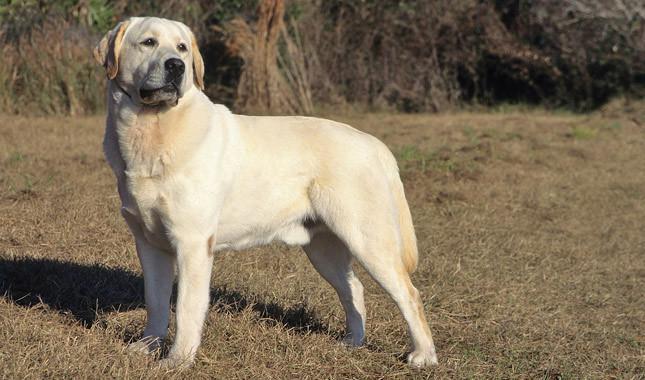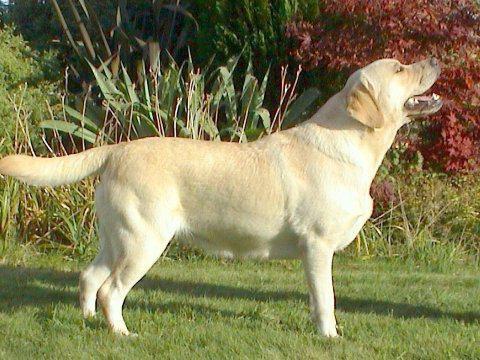The first image is the image on the left, the second image is the image on the right. Considering the images on both sides, is "There is one black dog" valid? Answer yes or no. No. 